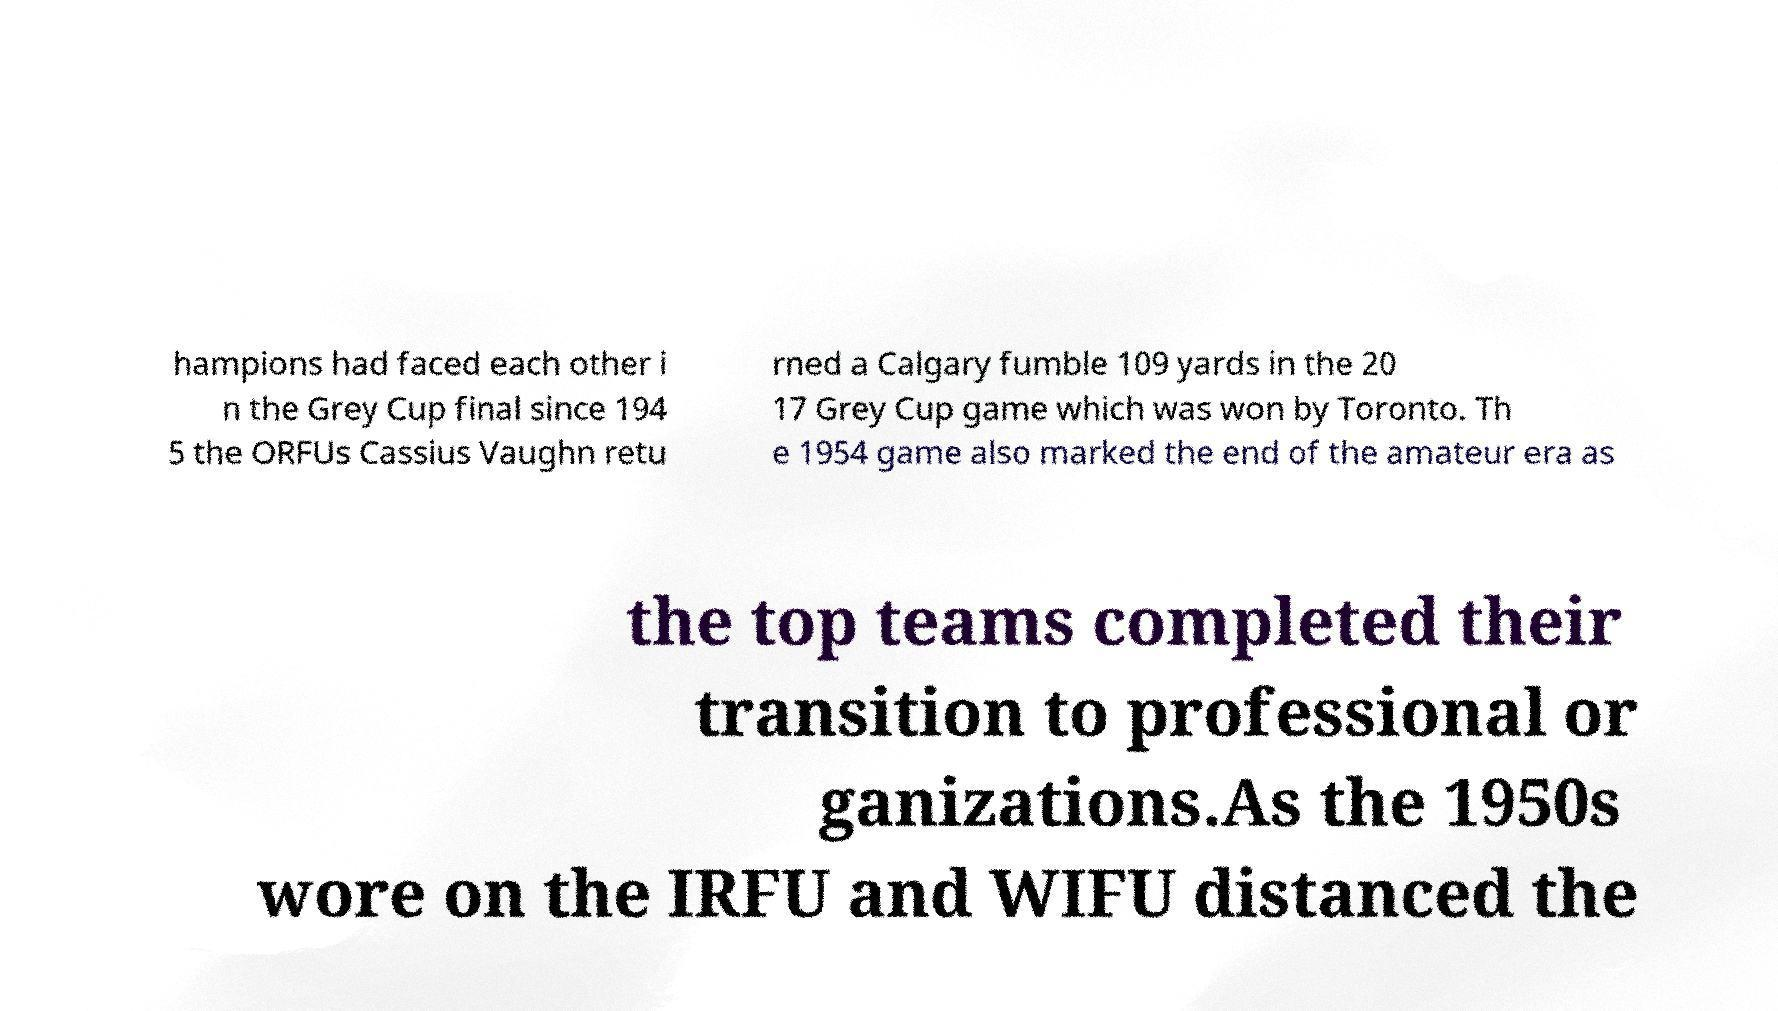What messages or text are displayed in this image? I need them in a readable, typed format. hampions had faced each other i n the Grey Cup final since 194 5 the ORFUs Cassius Vaughn retu rned a Calgary fumble 109 yards in the 20 17 Grey Cup game which was won by Toronto. Th e 1954 game also marked the end of the amateur era as the top teams completed their transition to professional or ganizations.As the 1950s wore on the IRFU and WIFU distanced the 